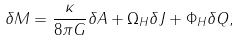<formula> <loc_0><loc_0><loc_500><loc_500>\delta M = \frac { \kappa } { 8 \pi G } \delta A + \Omega _ { H } \delta J + \Phi _ { H } \delta Q ,</formula> 